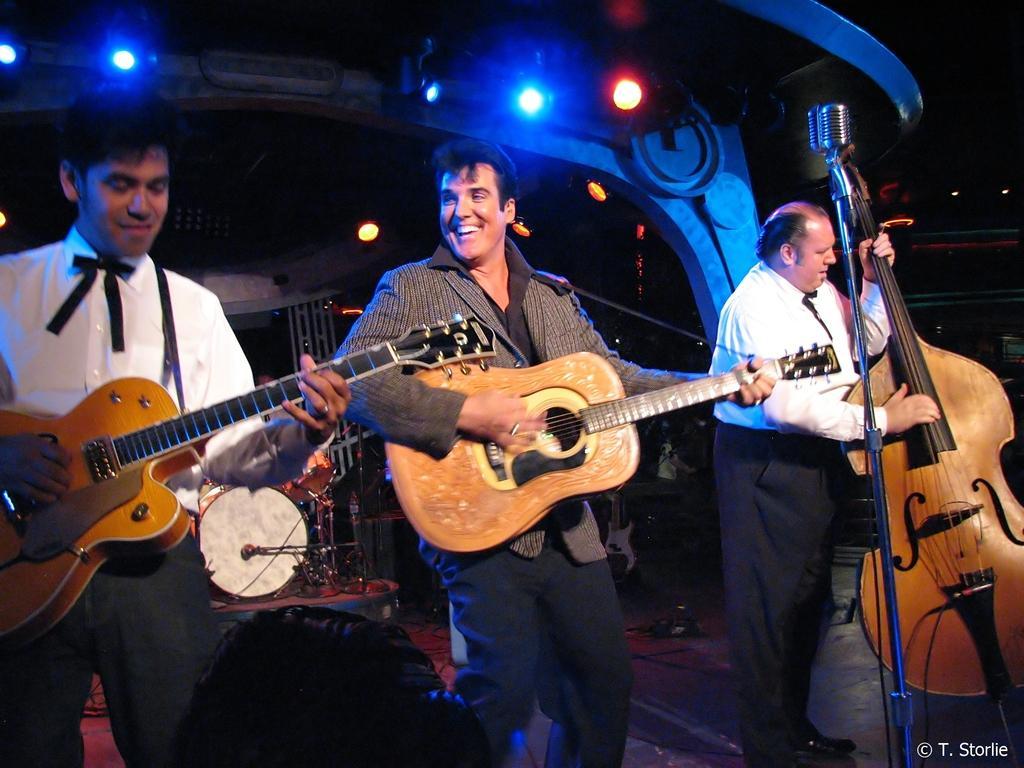How would you summarize this image in a sentence or two? Here we can see a group of people are standing and playing the guitar, and in front here is the mike, and at back here are the musical drums, and here are the lights. 